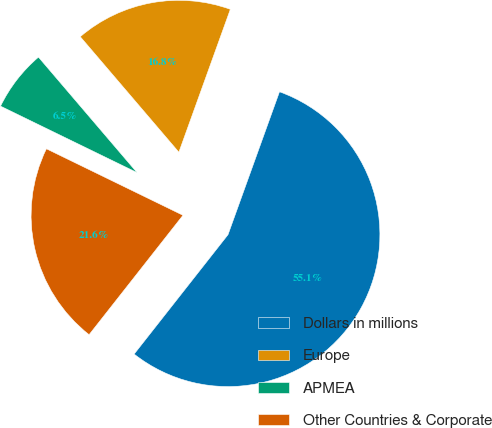Convert chart to OTSL. <chart><loc_0><loc_0><loc_500><loc_500><pie_chart><fcel>Dollars in millions<fcel>Europe<fcel>APMEA<fcel>Other Countries & Corporate<nl><fcel>55.1%<fcel>16.75%<fcel>6.54%<fcel>21.61%<nl></chart> 